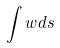Convert formula to latex. <formula><loc_0><loc_0><loc_500><loc_500>\int w d s</formula> 